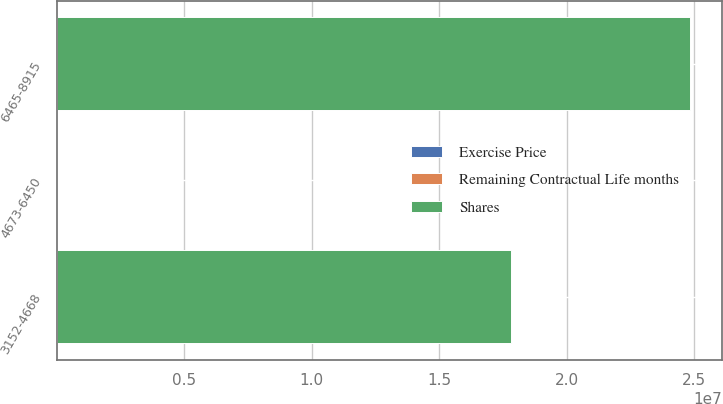Convert chart. <chart><loc_0><loc_0><loc_500><loc_500><stacked_bar_chart><ecel><fcel>3152-4668<fcel>4673-6450<fcel>6465-8915<nl><fcel>Shares<fcel>1.78068e+07<fcel>74.845<fcel>2.48262e+07<nl><fcel>Exercise Price<fcel>30<fcel>69<fcel>102<nl><fcel>Remaining Contractual Life months<fcel>43.3<fcel>59.37<fcel>80.69<nl></chart> 